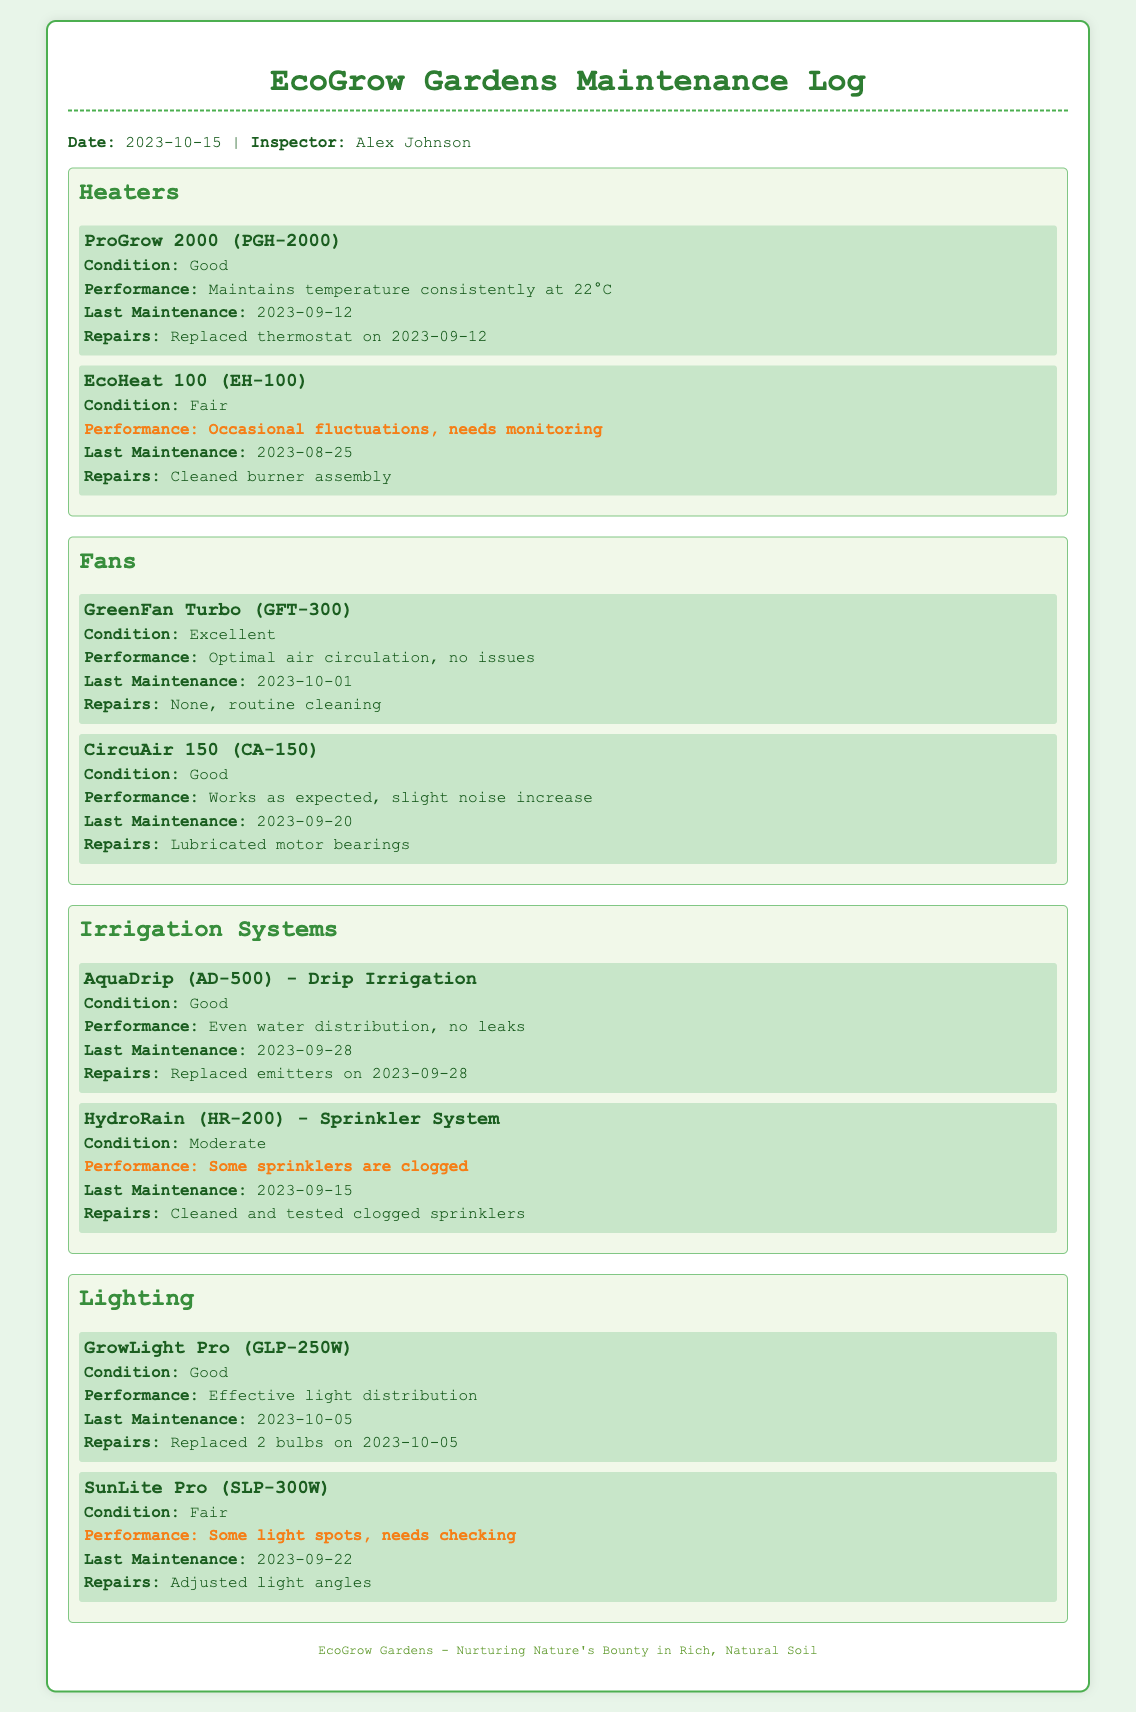what is the condition of the ProGrow 2000? The condition of the ProGrow 2000 is described in the document, indicating its status.
Answer: Good when was the last maintenance for the HydroRain? The document provides details about the last maintenance for the HydroRain sprinkler system, including the date.
Answer: 2023-09-15 what performance issue is noted for the EcoHeat 100? The performance of the EcoHeat 100 is explicitly described, detailing any issues that need attention.
Answer: Occasional fluctuations how many bulbs were replaced in the GrowLight Pro? The document includes specific information about the maintenance actions taken for the GrowLight Pro, including repairs performed.
Answer: 2 bulbs which fan has no reported issues? The document presents the status of two fans, focusing on performance and condition, highlighting any concerns.
Answer: GreenFan Turbo what was done during the last maintenance of the AquaDrip? The document details the repairs and actions taken during the last maintenance for the AquaDrip irrigation system.
Answer: Replaced emitters what is the condition of the SunLite Pro? The condition of the SunLite Pro is listed in the document, providing insights into its status for the time of inspection.
Answer: Fair is there a warning for the CircuAir 150? The document indicates any warnings present for the various equipment, particularly for the CircuAir 150 fan.
Answer: No how often are the heaters inspected? The document includes the last maintenance dates for each heater, hinting at the inspection frequency as well.
Answer: Monthly 